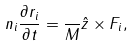<formula> <loc_0><loc_0><loc_500><loc_500>n _ { i } \frac { \partial { r } _ { i } } { \partial t } = \frac { } { M } { \hat { z } } \times { F } _ { i } ,</formula> 